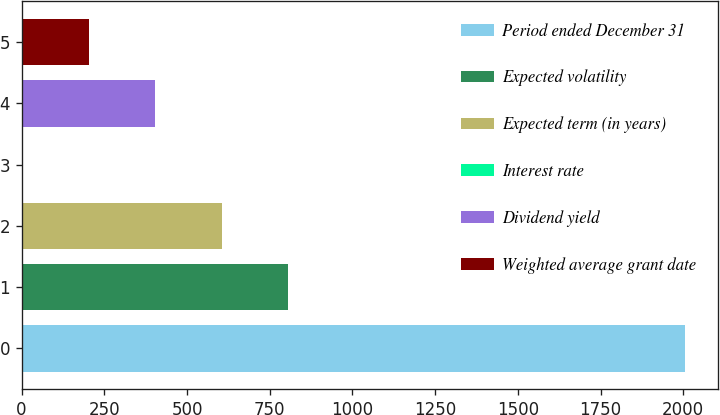Convert chart to OTSL. <chart><loc_0><loc_0><loc_500><loc_500><bar_chart><fcel>Period ended December 31<fcel>Expected volatility<fcel>Expected term (in years)<fcel>Interest rate<fcel>Dividend yield<fcel>Weighted average grant date<nl><fcel>2005<fcel>804.34<fcel>604.23<fcel>3.9<fcel>404.12<fcel>204.01<nl></chart> 